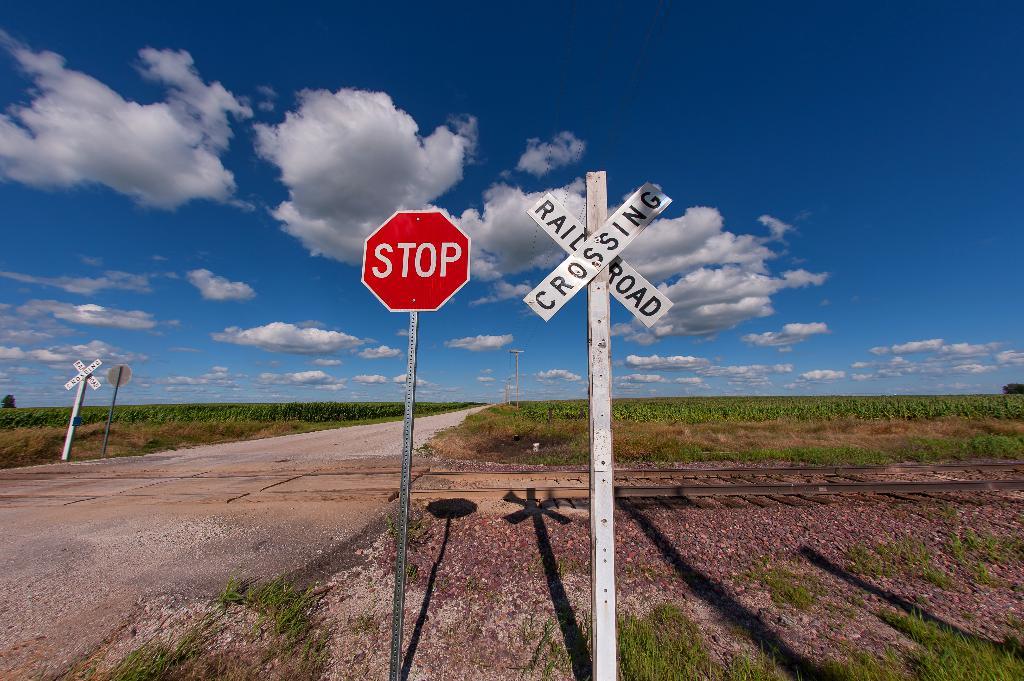What are these signs warning the drivers?
Offer a terse response. Railroad crossing. What kind of crossing?
Your response must be concise. Railroad. 